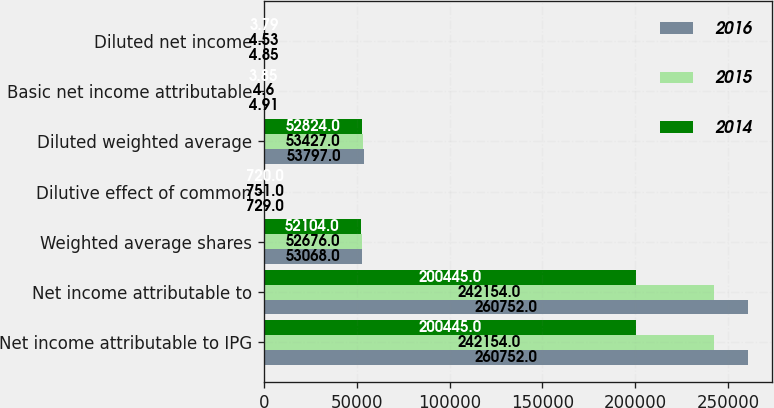Convert chart to OTSL. <chart><loc_0><loc_0><loc_500><loc_500><stacked_bar_chart><ecel><fcel>Net income attributable to IPG<fcel>Net income attributable to<fcel>Weighted average shares<fcel>Dilutive effect of common<fcel>Diluted weighted average<fcel>Basic net income attributable<fcel>Diluted net income<nl><fcel>2016<fcel>260752<fcel>260752<fcel>53068<fcel>729<fcel>53797<fcel>4.91<fcel>4.85<nl><fcel>2015<fcel>242154<fcel>242154<fcel>52676<fcel>751<fcel>53427<fcel>4.6<fcel>4.53<nl><fcel>2014<fcel>200445<fcel>200445<fcel>52104<fcel>720<fcel>52824<fcel>3.85<fcel>3.79<nl></chart> 